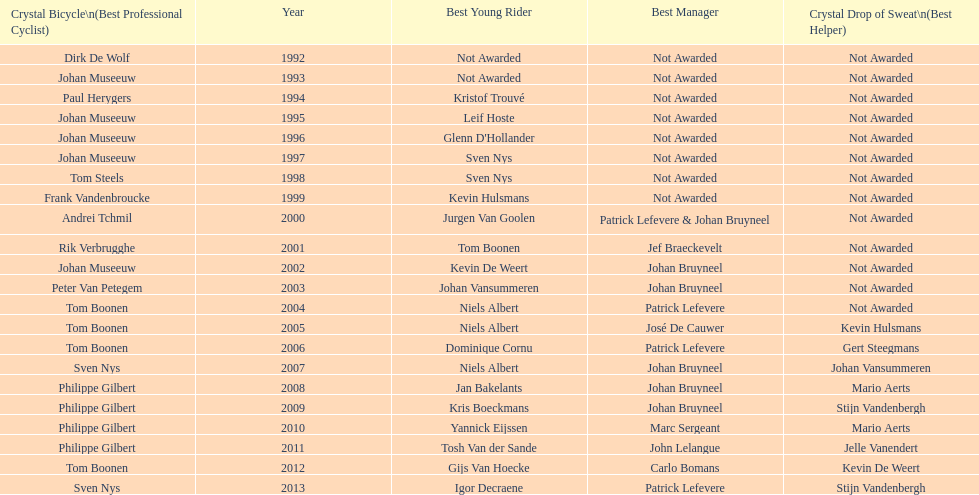Who won the most consecutive crystal bicycles? Philippe Gilbert. 